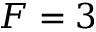Convert formula to latex. <formula><loc_0><loc_0><loc_500><loc_500>F = 3</formula> 